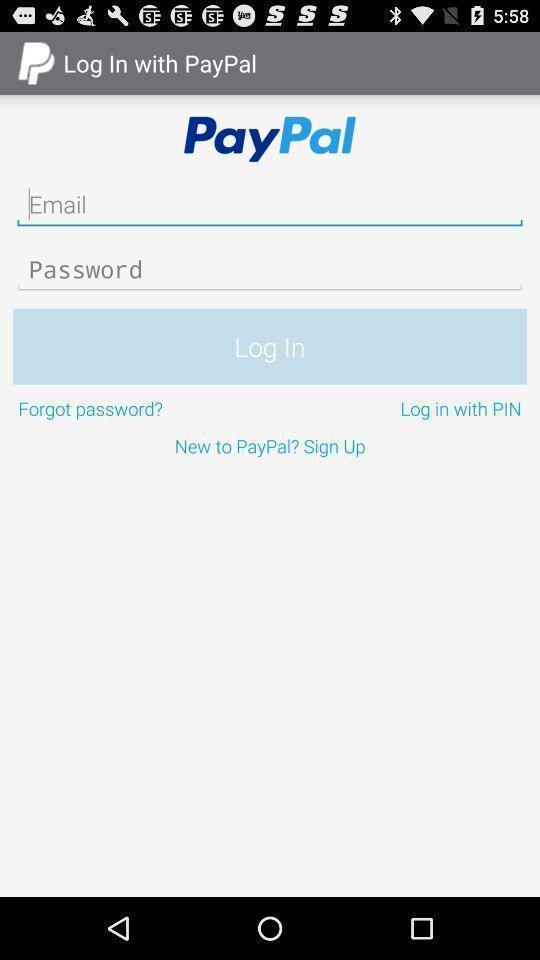Explain what's happening in this screen capture. Page asking to login to an account. 